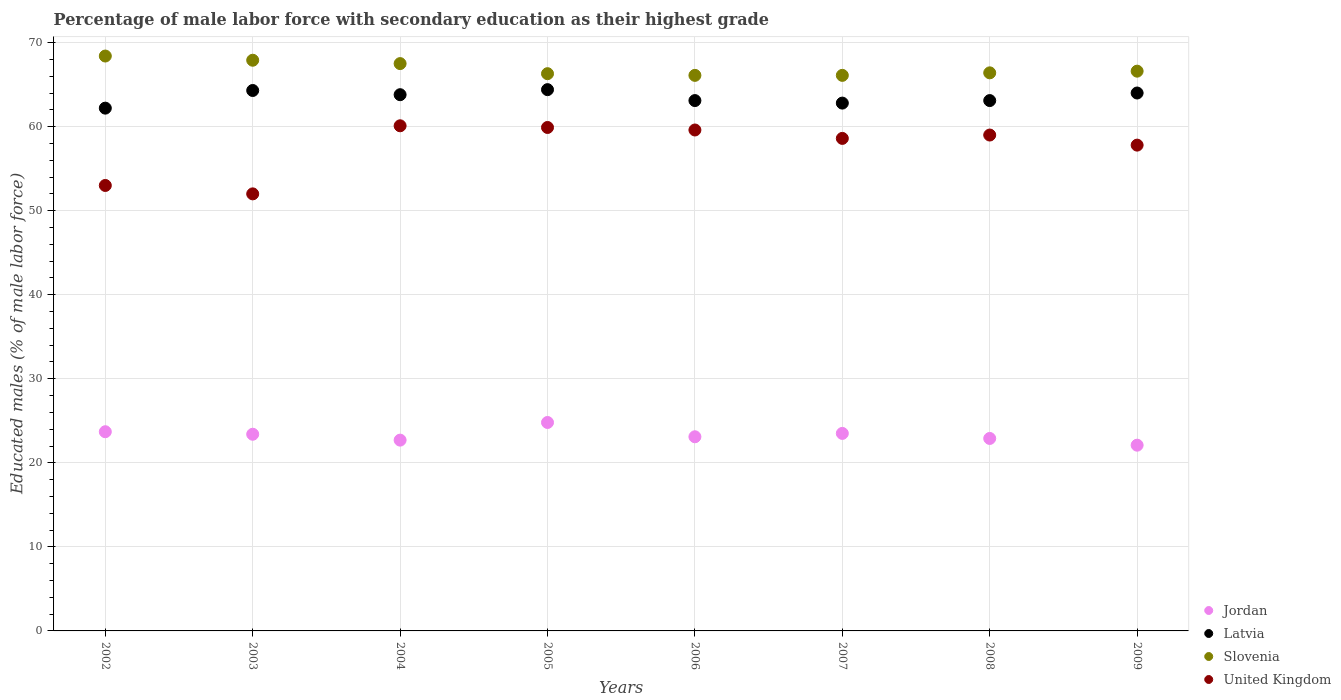What is the percentage of male labor force with secondary education in Slovenia in 2005?
Offer a very short reply. 66.3. Across all years, what is the maximum percentage of male labor force with secondary education in Jordan?
Offer a terse response. 24.8. Across all years, what is the minimum percentage of male labor force with secondary education in Latvia?
Provide a short and direct response. 62.2. What is the total percentage of male labor force with secondary education in Slovenia in the graph?
Provide a short and direct response. 535.3. What is the difference between the percentage of male labor force with secondary education in Jordan in 2004 and that in 2009?
Give a very brief answer. 0.6. What is the difference between the percentage of male labor force with secondary education in Slovenia in 2005 and the percentage of male labor force with secondary education in Latvia in 2009?
Your answer should be compact. 2.3. What is the average percentage of male labor force with secondary education in Slovenia per year?
Your answer should be compact. 66.91. In the year 2007, what is the difference between the percentage of male labor force with secondary education in United Kingdom and percentage of male labor force with secondary education in Latvia?
Provide a succinct answer. -4.2. In how many years, is the percentage of male labor force with secondary education in Jordan greater than 28 %?
Offer a terse response. 0. What is the ratio of the percentage of male labor force with secondary education in Jordan in 2002 to that in 2006?
Provide a short and direct response. 1.03. Is the difference between the percentage of male labor force with secondary education in United Kingdom in 2002 and 2004 greater than the difference between the percentage of male labor force with secondary education in Latvia in 2002 and 2004?
Keep it short and to the point. No. What is the difference between the highest and the lowest percentage of male labor force with secondary education in Jordan?
Your answer should be very brief. 2.7. How many dotlines are there?
Provide a succinct answer. 4. How many years are there in the graph?
Your answer should be very brief. 8. Are the values on the major ticks of Y-axis written in scientific E-notation?
Your response must be concise. No. Does the graph contain grids?
Offer a very short reply. Yes. How are the legend labels stacked?
Offer a terse response. Vertical. What is the title of the graph?
Make the answer very short. Percentage of male labor force with secondary education as their highest grade. What is the label or title of the Y-axis?
Your response must be concise. Educated males (% of male labor force). What is the Educated males (% of male labor force) in Jordan in 2002?
Give a very brief answer. 23.7. What is the Educated males (% of male labor force) in Latvia in 2002?
Offer a very short reply. 62.2. What is the Educated males (% of male labor force) of Slovenia in 2002?
Provide a succinct answer. 68.4. What is the Educated males (% of male labor force) of United Kingdom in 2002?
Provide a succinct answer. 53. What is the Educated males (% of male labor force) of Jordan in 2003?
Your response must be concise. 23.4. What is the Educated males (% of male labor force) in Latvia in 2003?
Your response must be concise. 64.3. What is the Educated males (% of male labor force) in Slovenia in 2003?
Ensure brevity in your answer.  67.9. What is the Educated males (% of male labor force) in Jordan in 2004?
Ensure brevity in your answer.  22.7. What is the Educated males (% of male labor force) of Latvia in 2004?
Make the answer very short. 63.8. What is the Educated males (% of male labor force) in Slovenia in 2004?
Make the answer very short. 67.5. What is the Educated males (% of male labor force) in United Kingdom in 2004?
Give a very brief answer. 60.1. What is the Educated males (% of male labor force) of Jordan in 2005?
Your response must be concise. 24.8. What is the Educated males (% of male labor force) of Latvia in 2005?
Your answer should be compact. 64.4. What is the Educated males (% of male labor force) in Slovenia in 2005?
Your response must be concise. 66.3. What is the Educated males (% of male labor force) of United Kingdom in 2005?
Provide a short and direct response. 59.9. What is the Educated males (% of male labor force) in Jordan in 2006?
Provide a succinct answer. 23.1. What is the Educated males (% of male labor force) in Latvia in 2006?
Provide a short and direct response. 63.1. What is the Educated males (% of male labor force) in Slovenia in 2006?
Ensure brevity in your answer.  66.1. What is the Educated males (% of male labor force) of United Kingdom in 2006?
Provide a short and direct response. 59.6. What is the Educated males (% of male labor force) of Latvia in 2007?
Your response must be concise. 62.8. What is the Educated males (% of male labor force) of Slovenia in 2007?
Your answer should be compact. 66.1. What is the Educated males (% of male labor force) of United Kingdom in 2007?
Give a very brief answer. 58.6. What is the Educated males (% of male labor force) of Jordan in 2008?
Keep it short and to the point. 22.9. What is the Educated males (% of male labor force) in Latvia in 2008?
Keep it short and to the point. 63.1. What is the Educated males (% of male labor force) in Slovenia in 2008?
Your response must be concise. 66.4. What is the Educated males (% of male labor force) of United Kingdom in 2008?
Give a very brief answer. 59. What is the Educated males (% of male labor force) of Jordan in 2009?
Provide a succinct answer. 22.1. What is the Educated males (% of male labor force) in Slovenia in 2009?
Provide a short and direct response. 66.6. What is the Educated males (% of male labor force) in United Kingdom in 2009?
Your answer should be very brief. 57.8. Across all years, what is the maximum Educated males (% of male labor force) of Jordan?
Offer a terse response. 24.8. Across all years, what is the maximum Educated males (% of male labor force) in Latvia?
Give a very brief answer. 64.4. Across all years, what is the maximum Educated males (% of male labor force) of Slovenia?
Provide a short and direct response. 68.4. Across all years, what is the maximum Educated males (% of male labor force) of United Kingdom?
Provide a succinct answer. 60.1. Across all years, what is the minimum Educated males (% of male labor force) of Jordan?
Give a very brief answer. 22.1. Across all years, what is the minimum Educated males (% of male labor force) in Latvia?
Your response must be concise. 62.2. Across all years, what is the minimum Educated males (% of male labor force) in Slovenia?
Make the answer very short. 66.1. What is the total Educated males (% of male labor force) of Jordan in the graph?
Keep it short and to the point. 186.2. What is the total Educated males (% of male labor force) in Latvia in the graph?
Offer a very short reply. 507.7. What is the total Educated males (% of male labor force) in Slovenia in the graph?
Give a very brief answer. 535.3. What is the total Educated males (% of male labor force) of United Kingdom in the graph?
Your response must be concise. 460. What is the difference between the Educated males (% of male labor force) of Jordan in 2002 and that in 2004?
Your response must be concise. 1. What is the difference between the Educated males (% of male labor force) in Latvia in 2002 and that in 2004?
Offer a terse response. -1.6. What is the difference between the Educated males (% of male labor force) of Slovenia in 2002 and that in 2004?
Give a very brief answer. 0.9. What is the difference between the Educated males (% of male labor force) in Jordan in 2002 and that in 2005?
Keep it short and to the point. -1.1. What is the difference between the Educated males (% of male labor force) of Latvia in 2002 and that in 2005?
Make the answer very short. -2.2. What is the difference between the Educated males (% of male labor force) of Jordan in 2002 and that in 2006?
Your response must be concise. 0.6. What is the difference between the Educated males (% of male labor force) of Latvia in 2002 and that in 2006?
Keep it short and to the point. -0.9. What is the difference between the Educated males (% of male labor force) of Slovenia in 2002 and that in 2006?
Offer a terse response. 2.3. What is the difference between the Educated males (% of male labor force) in Latvia in 2002 and that in 2008?
Keep it short and to the point. -0.9. What is the difference between the Educated males (% of male labor force) in Slovenia in 2002 and that in 2008?
Offer a very short reply. 2. What is the difference between the Educated males (% of male labor force) in United Kingdom in 2002 and that in 2008?
Your response must be concise. -6. What is the difference between the Educated males (% of male labor force) in Slovenia in 2002 and that in 2009?
Offer a terse response. 1.8. What is the difference between the Educated males (% of male labor force) in United Kingdom in 2002 and that in 2009?
Ensure brevity in your answer.  -4.8. What is the difference between the Educated males (% of male labor force) in Latvia in 2003 and that in 2004?
Provide a short and direct response. 0.5. What is the difference between the Educated males (% of male labor force) of Slovenia in 2003 and that in 2004?
Give a very brief answer. 0.4. What is the difference between the Educated males (% of male labor force) of Jordan in 2003 and that in 2005?
Offer a terse response. -1.4. What is the difference between the Educated males (% of male labor force) of Latvia in 2003 and that in 2005?
Provide a short and direct response. -0.1. What is the difference between the Educated males (% of male labor force) in Jordan in 2003 and that in 2006?
Your answer should be very brief. 0.3. What is the difference between the Educated males (% of male labor force) in Slovenia in 2003 and that in 2006?
Your answer should be very brief. 1.8. What is the difference between the Educated males (% of male labor force) of United Kingdom in 2003 and that in 2007?
Provide a short and direct response. -6.6. What is the difference between the Educated males (% of male labor force) in Slovenia in 2003 and that in 2008?
Offer a terse response. 1.5. What is the difference between the Educated males (% of male labor force) in United Kingdom in 2003 and that in 2008?
Give a very brief answer. -7. What is the difference between the Educated males (% of male labor force) in Latvia in 2003 and that in 2009?
Your answer should be very brief. 0.3. What is the difference between the Educated males (% of male labor force) of Jordan in 2004 and that in 2006?
Your answer should be very brief. -0.4. What is the difference between the Educated males (% of male labor force) in United Kingdom in 2004 and that in 2006?
Your response must be concise. 0.5. What is the difference between the Educated males (% of male labor force) in Slovenia in 2004 and that in 2007?
Your response must be concise. 1.4. What is the difference between the Educated males (% of male labor force) of Latvia in 2004 and that in 2008?
Keep it short and to the point. 0.7. What is the difference between the Educated males (% of male labor force) of Slovenia in 2004 and that in 2009?
Offer a terse response. 0.9. What is the difference between the Educated males (% of male labor force) of United Kingdom in 2004 and that in 2009?
Provide a succinct answer. 2.3. What is the difference between the Educated males (% of male labor force) of Jordan in 2005 and that in 2006?
Your response must be concise. 1.7. What is the difference between the Educated males (% of male labor force) of Latvia in 2005 and that in 2006?
Provide a short and direct response. 1.3. What is the difference between the Educated males (% of male labor force) of Jordan in 2005 and that in 2007?
Give a very brief answer. 1.3. What is the difference between the Educated males (% of male labor force) of United Kingdom in 2005 and that in 2007?
Ensure brevity in your answer.  1.3. What is the difference between the Educated males (% of male labor force) in United Kingdom in 2005 and that in 2008?
Offer a terse response. 0.9. What is the difference between the Educated males (% of male labor force) of United Kingdom in 2005 and that in 2009?
Give a very brief answer. 2.1. What is the difference between the Educated males (% of male labor force) in Latvia in 2006 and that in 2007?
Make the answer very short. 0.3. What is the difference between the Educated males (% of male labor force) in Slovenia in 2006 and that in 2007?
Make the answer very short. 0. What is the difference between the Educated males (% of male labor force) of United Kingdom in 2006 and that in 2007?
Offer a very short reply. 1. What is the difference between the Educated males (% of male labor force) in Slovenia in 2006 and that in 2008?
Offer a terse response. -0.3. What is the difference between the Educated males (% of male labor force) of United Kingdom in 2006 and that in 2008?
Your answer should be compact. 0.6. What is the difference between the Educated males (% of male labor force) in Latvia in 2006 and that in 2009?
Give a very brief answer. -0.9. What is the difference between the Educated males (% of male labor force) in United Kingdom in 2006 and that in 2009?
Keep it short and to the point. 1.8. What is the difference between the Educated males (% of male labor force) of Jordan in 2007 and that in 2008?
Offer a terse response. 0.6. What is the difference between the Educated males (% of male labor force) of Latvia in 2007 and that in 2008?
Give a very brief answer. -0.3. What is the difference between the Educated males (% of male labor force) in Latvia in 2007 and that in 2009?
Provide a succinct answer. -1.2. What is the difference between the Educated males (% of male labor force) in United Kingdom in 2007 and that in 2009?
Give a very brief answer. 0.8. What is the difference between the Educated males (% of male labor force) of Latvia in 2008 and that in 2009?
Offer a very short reply. -0.9. What is the difference between the Educated males (% of male labor force) of Slovenia in 2008 and that in 2009?
Your response must be concise. -0.2. What is the difference between the Educated males (% of male labor force) in United Kingdom in 2008 and that in 2009?
Ensure brevity in your answer.  1.2. What is the difference between the Educated males (% of male labor force) of Jordan in 2002 and the Educated males (% of male labor force) of Latvia in 2003?
Your response must be concise. -40.6. What is the difference between the Educated males (% of male labor force) of Jordan in 2002 and the Educated males (% of male labor force) of Slovenia in 2003?
Offer a very short reply. -44.2. What is the difference between the Educated males (% of male labor force) of Jordan in 2002 and the Educated males (% of male labor force) of United Kingdom in 2003?
Give a very brief answer. -28.3. What is the difference between the Educated males (% of male labor force) in Latvia in 2002 and the Educated males (% of male labor force) in Slovenia in 2003?
Give a very brief answer. -5.7. What is the difference between the Educated males (% of male labor force) in Latvia in 2002 and the Educated males (% of male labor force) in United Kingdom in 2003?
Your response must be concise. 10.2. What is the difference between the Educated males (% of male labor force) of Slovenia in 2002 and the Educated males (% of male labor force) of United Kingdom in 2003?
Your answer should be very brief. 16.4. What is the difference between the Educated males (% of male labor force) of Jordan in 2002 and the Educated males (% of male labor force) of Latvia in 2004?
Offer a terse response. -40.1. What is the difference between the Educated males (% of male labor force) of Jordan in 2002 and the Educated males (% of male labor force) of Slovenia in 2004?
Keep it short and to the point. -43.8. What is the difference between the Educated males (% of male labor force) in Jordan in 2002 and the Educated males (% of male labor force) in United Kingdom in 2004?
Ensure brevity in your answer.  -36.4. What is the difference between the Educated males (% of male labor force) of Latvia in 2002 and the Educated males (% of male labor force) of Slovenia in 2004?
Keep it short and to the point. -5.3. What is the difference between the Educated males (% of male labor force) in Slovenia in 2002 and the Educated males (% of male labor force) in United Kingdom in 2004?
Ensure brevity in your answer.  8.3. What is the difference between the Educated males (% of male labor force) of Jordan in 2002 and the Educated males (% of male labor force) of Latvia in 2005?
Your answer should be compact. -40.7. What is the difference between the Educated males (% of male labor force) in Jordan in 2002 and the Educated males (% of male labor force) in Slovenia in 2005?
Your response must be concise. -42.6. What is the difference between the Educated males (% of male labor force) of Jordan in 2002 and the Educated males (% of male labor force) of United Kingdom in 2005?
Keep it short and to the point. -36.2. What is the difference between the Educated males (% of male labor force) of Latvia in 2002 and the Educated males (% of male labor force) of United Kingdom in 2005?
Offer a very short reply. 2.3. What is the difference between the Educated males (% of male labor force) of Jordan in 2002 and the Educated males (% of male labor force) of Latvia in 2006?
Your answer should be very brief. -39.4. What is the difference between the Educated males (% of male labor force) of Jordan in 2002 and the Educated males (% of male labor force) of Slovenia in 2006?
Keep it short and to the point. -42.4. What is the difference between the Educated males (% of male labor force) in Jordan in 2002 and the Educated males (% of male labor force) in United Kingdom in 2006?
Offer a very short reply. -35.9. What is the difference between the Educated males (% of male labor force) of Slovenia in 2002 and the Educated males (% of male labor force) of United Kingdom in 2006?
Your answer should be very brief. 8.8. What is the difference between the Educated males (% of male labor force) of Jordan in 2002 and the Educated males (% of male labor force) of Latvia in 2007?
Offer a very short reply. -39.1. What is the difference between the Educated males (% of male labor force) in Jordan in 2002 and the Educated males (% of male labor force) in Slovenia in 2007?
Your response must be concise. -42.4. What is the difference between the Educated males (% of male labor force) in Jordan in 2002 and the Educated males (% of male labor force) in United Kingdom in 2007?
Make the answer very short. -34.9. What is the difference between the Educated males (% of male labor force) in Latvia in 2002 and the Educated males (% of male labor force) in United Kingdom in 2007?
Keep it short and to the point. 3.6. What is the difference between the Educated males (% of male labor force) in Slovenia in 2002 and the Educated males (% of male labor force) in United Kingdom in 2007?
Ensure brevity in your answer.  9.8. What is the difference between the Educated males (% of male labor force) in Jordan in 2002 and the Educated males (% of male labor force) in Latvia in 2008?
Ensure brevity in your answer.  -39.4. What is the difference between the Educated males (% of male labor force) in Jordan in 2002 and the Educated males (% of male labor force) in Slovenia in 2008?
Make the answer very short. -42.7. What is the difference between the Educated males (% of male labor force) of Jordan in 2002 and the Educated males (% of male labor force) of United Kingdom in 2008?
Your response must be concise. -35.3. What is the difference between the Educated males (% of male labor force) in Latvia in 2002 and the Educated males (% of male labor force) in United Kingdom in 2008?
Give a very brief answer. 3.2. What is the difference between the Educated males (% of male labor force) of Jordan in 2002 and the Educated males (% of male labor force) of Latvia in 2009?
Give a very brief answer. -40.3. What is the difference between the Educated males (% of male labor force) in Jordan in 2002 and the Educated males (% of male labor force) in Slovenia in 2009?
Provide a short and direct response. -42.9. What is the difference between the Educated males (% of male labor force) of Jordan in 2002 and the Educated males (% of male labor force) of United Kingdom in 2009?
Provide a succinct answer. -34.1. What is the difference between the Educated males (% of male labor force) in Latvia in 2002 and the Educated males (% of male labor force) in Slovenia in 2009?
Give a very brief answer. -4.4. What is the difference between the Educated males (% of male labor force) in Latvia in 2002 and the Educated males (% of male labor force) in United Kingdom in 2009?
Offer a very short reply. 4.4. What is the difference between the Educated males (% of male labor force) of Slovenia in 2002 and the Educated males (% of male labor force) of United Kingdom in 2009?
Make the answer very short. 10.6. What is the difference between the Educated males (% of male labor force) in Jordan in 2003 and the Educated males (% of male labor force) in Latvia in 2004?
Give a very brief answer. -40.4. What is the difference between the Educated males (% of male labor force) of Jordan in 2003 and the Educated males (% of male labor force) of Slovenia in 2004?
Provide a short and direct response. -44.1. What is the difference between the Educated males (% of male labor force) in Jordan in 2003 and the Educated males (% of male labor force) in United Kingdom in 2004?
Offer a very short reply. -36.7. What is the difference between the Educated males (% of male labor force) in Latvia in 2003 and the Educated males (% of male labor force) in Slovenia in 2004?
Keep it short and to the point. -3.2. What is the difference between the Educated males (% of male labor force) in Slovenia in 2003 and the Educated males (% of male labor force) in United Kingdom in 2004?
Keep it short and to the point. 7.8. What is the difference between the Educated males (% of male labor force) in Jordan in 2003 and the Educated males (% of male labor force) in Latvia in 2005?
Provide a succinct answer. -41. What is the difference between the Educated males (% of male labor force) of Jordan in 2003 and the Educated males (% of male labor force) of Slovenia in 2005?
Keep it short and to the point. -42.9. What is the difference between the Educated males (% of male labor force) in Jordan in 2003 and the Educated males (% of male labor force) in United Kingdom in 2005?
Offer a very short reply. -36.5. What is the difference between the Educated males (% of male labor force) in Latvia in 2003 and the Educated males (% of male labor force) in Slovenia in 2005?
Make the answer very short. -2. What is the difference between the Educated males (% of male labor force) of Jordan in 2003 and the Educated males (% of male labor force) of Latvia in 2006?
Ensure brevity in your answer.  -39.7. What is the difference between the Educated males (% of male labor force) of Jordan in 2003 and the Educated males (% of male labor force) of Slovenia in 2006?
Provide a succinct answer. -42.7. What is the difference between the Educated males (% of male labor force) in Jordan in 2003 and the Educated males (% of male labor force) in United Kingdom in 2006?
Make the answer very short. -36.2. What is the difference between the Educated males (% of male labor force) of Jordan in 2003 and the Educated males (% of male labor force) of Latvia in 2007?
Your answer should be very brief. -39.4. What is the difference between the Educated males (% of male labor force) of Jordan in 2003 and the Educated males (% of male labor force) of Slovenia in 2007?
Keep it short and to the point. -42.7. What is the difference between the Educated males (% of male labor force) in Jordan in 2003 and the Educated males (% of male labor force) in United Kingdom in 2007?
Provide a short and direct response. -35.2. What is the difference between the Educated males (% of male labor force) in Latvia in 2003 and the Educated males (% of male labor force) in Slovenia in 2007?
Your response must be concise. -1.8. What is the difference between the Educated males (% of male labor force) of Jordan in 2003 and the Educated males (% of male labor force) of Latvia in 2008?
Ensure brevity in your answer.  -39.7. What is the difference between the Educated males (% of male labor force) of Jordan in 2003 and the Educated males (% of male labor force) of Slovenia in 2008?
Provide a short and direct response. -43. What is the difference between the Educated males (% of male labor force) in Jordan in 2003 and the Educated males (% of male labor force) in United Kingdom in 2008?
Give a very brief answer. -35.6. What is the difference between the Educated males (% of male labor force) of Latvia in 2003 and the Educated males (% of male labor force) of Slovenia in 2008?
Keep it short and to the point. -2.1. What is the difference between the Educated males (% of male labor force) in Latvia in 2003 and the Educated males (% of male labor force) in United Kingdom in 2008?
Make the answer very short. 5.3. What is the difference between the Educated males (% of male labor force) in Jordan in 2003 and the Educated males (% of male labor force) in Latvia in 2009?
Keep it short and to the point. -40.6. What is the difference between the Educated males (% of male labor force) in Jordan in 2003 and the Educated males (% of male labor force) in Slovenia in 2009?
Ensure brevity in your answer.  -43.2. What is the difference between the Educated males (% of male labor force) in Jordan in 2003 and the Educated males (% of male labor force) in United Kingdom in 2009?
Offer a very short reply. -34.4. What is the difference between the Educated males (% of male labor force) of Jordan in 2004 and the Educated males (% of male labor force) of Latvia in 2005?
Ensure brevity in your answer.  -41.7. What is the difference between the Educated males (% of male labor force) of Jordan in 2004 and the Educated males (% of male labor force) of Slovenia in 2005?
Make the answer very short. -43.6. What is the difference between the Educated males (% of male labor force) in Jordan in 2004 and the Educated males (% of male labor force) in United Kingdom in 2005?
Provide a short and direct response. -37.2. What is the difference between the Educated males (% of male labor force) in Latvia in 2004 and the Educated males (% of male labor force) in United Kingdom in 2005?
Your answer should be very brief. 3.9. What is the difference between the Educated males (% of male labor force) of Jordan in 2004 and the Educated males (% of male labor force) of Latvia in 2006?
Your answer should be compact. -40.4. What is the difference between the Educated males (% of male labor force) of Jordan in 2004 and the Educated males (% of male labor force) of Slovenia in 2006?
Your response must be concise. -43.4. What is the difference between the Educated males (% of male labor force) in Jordan in 2004 and the Educated males (% of male labor force) in United Kingdom in 2006?
Offer a very short reply. -36.9. What is the difference between the Educated males (% of male labor force) of Latvia in 2004 and the Educated males (% of male labor force) of Slovenia in 2006?
Your answer should be compact. -2.3. What is the difference between the Educated males (% of male labor force) of Jordan in 2004 and the Educated males (% of male labor force) of Latvia in 2007?
Ensure brevity in your answer.  -40.1. What is the difference between the Educated males (% of male labor force) in Jordan in 2004 and the Educated males (% of male labor force) in Slovenia in 2007?
Offer a terse response. -43.4. What is the difference between the Educated males (% of male labor force) in Jordan in 2004 and the Educated males (% of male labor force) in United Kingdom in 2007?
Give a very brief answer. -35.9. What is the difference between the Educated males (% of male labor force) of Latvia in 2004 and the Educated males (% of male labor force) of United Kingdom in 2007?
Keep it short and to the point. 5.2. What is the difference between the Educated males (% of male labor force) in Jordan in 2004 and the Educated males (% of male labor force) in Latvia in 2008?
Keep it short and to the point. -40.4. What is the difference between the Educated males (% of male labor force) in Jordan in 2004 and the Educated males (% of male labor force) in Slovenia in 2008?
Provide a short and direct response. -43.7. What is the difference between the Educated males (% of male labor force) in Jordan in 2004 and the Educated males (% of male labor force) in United Kingdom in 2008?
Your answer should be compact. -36.3. What is the difference between the Educated males (% of male labor force) in Latvia in 2004 and the Educated males (% of male labor force) in Slovenia in 2008?
Provide a short and direct response. -2.6. What is the difference between the Educated males (% of male labor force) in Slovenia in 2004 and the Educated males (% of male labor force) in United Kingdom in 2008?
Provide a short and direct response. 8.5. What is the difference between the Educated males (% of male labor force) in Jordan in 2004 and the Educated males (% of male labor force) in Latvia in 2009?
Ensure brevity in your answer.  -41.3. What is the difference between the Educated males (% of male labor force) in Jordan in 2004 and the Educated males (% of male labor force) in Slovenia in 2009?
Provide a succinct answer. -43.9. What is the difference between the Educated males (% of male labor force) in Jordan in 2004 and the Educated males (% of male labor force) in United Kingdom in 2009?
Give a very brief answer. -35.1. What is the difference between the Educated males (% of male labor force) in Jordan in 2005 and the Educated males (% of male labor force) in Latvia in 2006?
Offer a terse response. -38.3. What is the difference between the Educated males (% of male labor force) in Jordan in 2005 and the Educated males (% of male labor force) in Slovenia in 2006?
Give a very brief answer. -41.3. What is the difference between the Educated males (% of male labor force) of Jordan in 2005 and the Educated males (% of male labor force) of United Kingdom in 2006?
Ensure brevity in your answer.  -34.8. What is the difference between the Educated males (% of male labor force) of Latvia in 2005 and the Educated males (% of male labor force) of United Kingdom in 2006?
Offer a terse response. 4.8. What is the difference between the Educated males (% of male labor force) of Jordan in 2005 and the Educated males (% of male labor force) of Latvia in 2007?
Your answer should be compact. -38. What is the difference between the Educated males (% of male labor force) in Jordan in 2005 and the Educated males (% of male labor force) in Slovenia in 2007?
Give a very brief answer. -41.3. What is the difference between the Educated males (% of male labor force) of Jordan in 2005 and the Educated males (% of male labor force) of United Kingdom in 2007?
Provide a short and direct response. -33.8. What is the difference between the Educated males (% of male labor force) in Latvia in 2005 and the Educated males (% of male labor force) in Slovenia in 2007?
Your answer should be compact. -1.7. What is the difference between the Educated males (% of male labor force) in Latvia in 2005 and the Educated males (% of male labor force) in United Kingdom in 2007?
Keep it short and to the point. 5.8. What is the difference between the Educated males (% of male labor force) in Slovenia in 2005 and the Educated males (% of male labor force) in United Kingdom in 2007?
Provide a short and direct response. 7.7. What is the difference between the Educated males (% of male labor force) of Jordan in 2005 and the Educated males (% of male labor force) of Latvia in 2008?
Your answer should be very brief. -38.3. What is the difference between the Educated males (% of male labor force) in Jordan in 2005 and the Educated males (% of male labor force) in Slovenia in 2008?
Provide a short and direct response. -41.6. What is the difference between the Educated males (% of male labor force) of Jordan in 2005 and the Educated males (% of male labor force) of United Kingdom in 2008?
Give a very brief answer. -34.2. What is the difference between the Educated males (% of male labor force) of Latvia in 2005 and the Educated males (% of male labor force) of Slovenia in 2008?
Provide a short and direct response. -2. What is the difference between the Educated males (% of male labor force) in Latvia in 2005 and the Educated males (% of male labor force) in United Kingdom in 2008?
Offer a terse response. 5.4. What is the difference between the Educated males (% of male labor force) in Jordan in 2005 and the Educated males (% of male labor force) in Latvia in 2009?
Offer a terse response. -39.2. What is the difference between the Educated males (% of male labor force) of Jordan in 2005 and the Educated males (% of male labor force) of Slovenia in 2009?
Ensure brevity in your answer.  -41.8. What is the difference between the Educated males (% of male labor force) in Jordan in 2005 and the Educated males (% of male labor force) in United Kingdom in 2009?
Ensure brevity in your answer.  -33. What is the difference between the Educated males (% of male labor force) of Latvia in 2005 and the Educated males (% of male labor force) of Slovenia in 2009?
Provide a succinct answer. -2.2. What is the difference between the Educated males (% of male labor force) in Slovenia in 2005 and the Educated males (% of male labor force) in United Kingdom in 2009?
Make the answer very short. 8.5. What is the difference between the Educated males (% of male labor force) in Jordan in 2006 and the Educated males (% of male labor force) in Latvia in 2007?
Ensure brevity in your answer.  -39.7. What is the difference between the Educated males (% of male labor force) of Jordan in 2006 and the Educated males (% of male labor force) of Slovenia in 2007?
Offer a terse response. -43. What is the difference between the Educated males (% of male labor force) of Jordan in 2006 and the Educated males (% of male labor force) of United Kingdom in 2007?
Offer a very short reply. -35.5. What is the difference between the Educated males (% of male labor force) in Latvia in 2006 and the Educated males (% of male labor force) in United Kingdom in 2007?
Your answer should be very brief. 4.5. What is the difference between the Educated males (% of male labor force) in Slovenia in 2006 and the Educated males (% of male labor force) in United Kingdom in 2007?
Provide a succinct answer. 7.5. What is the difference between the Educated males (% of male labor force) in Jordan in 2006 and the Educated males (% of male labor force) in Latvia in 2008?
Make the answer very short. -40. What is the difference between the Educated males (% of male labor force) in Jordan in 2006 and the Educated males (% of male labor force) in Slovenia in 2008?
Offer a very short reply. -43.3. What is the difference between the Educated males (% of male labor force) in Jordan in 2006 and the Educated males (% of male labor force) in United Kingdom in 2008?
Give a very brief answer. -35.9. What is the difference between the Educated males (% of male labor force) of Latvia in 2006 and the Educated males (% of male labor force) of United Kingdom in 2008?
Make the answer very short. 4.1. What is the difference between the Educated males (% of male labor force) in Jordan in 2006 and the Educated males (% of male labor force) in Latvia in 2009?
Ensure brevity in your answer.  -40.9. What is the difference between the Educated males (% of male labor force) of Jordan in 2006 and the Educated males (% of male labor force) of Slovenia in 2009?
Offer a very short reply. -43.5. What is the difference between the Educated males (% of male labor force) of Jordan in 2006 and the Educated males (% of male labor force) of United Kingdom in 2009?
Keep it short and to the point. -34.7. What is the difference between the Educated males (% of male labor force) of Latvia in 2006 and the Educated males (% of male labor force) of United Kingdom in 2009?
Ensure brevity in your answer.  5.3. What is the difference between the Educated males (% of male labor force) in Slovenia in 2006 and the Educated males (% of male labor force) in United Kingdom in 2009?
Offer a very short reply. 8.3. What is the difference between the Educated males (% of male labor force) of Jordan in 2007 and the Educated males (% of male labor force) of Latvia in 2008?
Give a very brief answer. -39.6. What is the difference between the Educated males (% of male labor force) of Jordan in 2007 and the Educated males (% of male labor force) of Slovenia in 2008?
Make the answer very short. -42.9. What is the difference between the Educated males (% of male labor force) of Jordan in 2007 and the Educated males (% of male labor force) of United Kingdom in 2008?
Make the answer very short. -35.5. What is the difference between the Educated males (% of male labor force) of Jordan in 2007 and the Educated males (% of male labor force) of Latvia in 2009?
Your answer should be compact. -40.5. What is the difference between the Educated males (% of male labor force) in Jordan in 2007 and the Educated males (% of male labor force) in Slovenia in 2009?
Your answer should be very brief. -43.1. What is the difference between the Educated males (% of male labor force) in Jordan in 2007 and the Educated males (% of male labor force) in United Kingdom in 2009?
Give a very brief answer. -34.3. What is the difference between the Educated males (% of male labor force) in Latvia in 2007 and the Educated males (% of male labor force) in Slovenia in 2009?
Offer a terse response. -3.8. What is the difference between the Educated males (% of male labor force) of Jordan in 2008 and the Educated males (% of male labor force) of Latvia in 2009?
Offer a very short reply. -41.1. What is the difference between the Educated males (% of male labor force) in Jordan in 2008 and the Educated males (% of male labor force) in Slovenia in 2009?
Provide a short and direct response. -43.7. What is the difference between the Educated males (% of male labor force) of Jordan in 2008 and the Educated males (% of male labor force) of United Kingdom in 2009?
Ensure brevity in your answer.  -34.9. What is the difference between the Educated males (% of male labor force) of Latvia in 2008 and the Educated males (% of male labor force) of United Kingdom in 2009?
Keep it short and to the point. 5.3. What is the average Educated males (% of male labor force) in Jordan per year?
Your answer should be compact. 23.27. What is the average Educated males (% of male labor force) in Latvia per year?
Make the answer very short. 63.46. What is the average Educated males (% of male labor force) in Slovenia per year?
Keep it short and to the point. 66.91. What is the average Educated males (% of male labor force) of United Kingdom per year?
Provide a succinct answer. 57.5. In the year 2002, what is the difference between the Educated males (% of male labor force) of Jordan and Educated males (% of male labor force) of Latvia?
Provide a succinct answer. -38.5. In the year 2002, what is the difference between the Educated males (% of male labor force) of Jordan and Educated males (% of male labor force) of Slovenia?
Offer a very short reply. -44.7. In the year 2002, what is the difference between the Educated males (% of male labor force) of Jordan and Educated males (% of male labor force) of United Kingdom?
Make the answer very short. -29.3. In the year 2002, what is the difference between the Educated males (% of male labor force) of Latvia and Educated males (% of male labor force) of United Kingdom?
Offer a very short reply. 9.2. In the year 2003, what is the difference between the Educated males (% of male labor force) of Jordan and Educated males (% of male labor force) of Latvia?
Offer a very short reply. -40.9. In the year 2003, what is the difference between the Educated males (% of male labor force) in Jordan and Educated males (% of male labor force) in Slovenia?
Provide a succinct answer. -44.5. In the year 2003, what is the difference between the Educated males (% of male labor force) in Jordan and Educated males (% of male labor force) in United Kingdom?
Make the answer very short. -28.6. In the year 2003, what is the difference between the Educated males (% of male labor force) of Latvia and Educated males (% of male labor force) of Slovenia?
Keep it short and to the point. -3.6. In the year 2003, what is the difference between the Educated males (% of male labor force) in Latvia and Educated males (% of male labor force) in United Kingdom?
Your response must be concise. 12.3. In the year 2004, what is the difference between the Educated males (% of male labor force) in Jordan and Educated males (% of male labor force) in Latvia?
Provide a short and direct response. -41.1. In the year 2004, what is the difference between the Educated males (% of male labor force) in Jordan and Educated males (% of male labor force) in Slovenia?
Ensure brevity in your answer.  -44.8. In the year 2004, what is the difference between the Educated males (% of male labor force) of Jordan and Educated males (% of male labor force) of United Kingdom?
Give a very brief answer. -37.4. In the year 2004, what is the difference between the Educated males (% of male labor force) in Slovenia and Educated males (% of male labor force) in United Kingdom?
Your answer should be very brief. 7.4. In the year 2005, what is the difference between the Educated males (% of male labor force) in Jordan and Educated males (% of male labor force) in Latvia?
Give a very brief answer. -39.6. In the year 2005, what is the difference between the Educated males (% of male labor force) in Jordan and Educated males (% of male labor force) in Slovenia?
Provide a succinct answer. -41.5. In the year 2005, what is the difference between the Educated males (% of male labor force) in Jordan and Educated males (% of male labor force) in United Kingdom?
Ensure brevity in your answer.  -35.1. In the year 2005, what is the difference between the Educated males (% of male labor force) in Latvia and Educated males (% of male labor force) in United Kingdom?
Provide a short and direct response. 4.5. In the year 2005, what is the difference between the Educated males (% of male labor force) of Slovenia and Educated males (% of male labor force) of United Kingdom?
Your response must be concise. 6.4. In the year 2006, what is the difference between the Educated males (% of male labor force) in Jordan and Educated males (% of male labor force) in Latvia?
Your answer should be very brief. -40. In the year 2006, what is the difference between the Educated males (% of male labor force) in Jordan and Educated males (% of male labor force) in Slovenia?
Keep it short and to the point. -43. In the year 2006, what is the difference between the Educated males (% of male labor force) in Jordan and Educated males (% of male labor force) in United Kingdom?
Give a very brief answer. -36.5. In the year 2006, what is the difference between the Educated males (% of male labor force) of Slovenia and Educated males (% of male labor force) of United Kingdom?
Provide a short and direct response. 6.5. In the year 2007, what is the difference between the Educated males (% of male labor force) of Jordan and Educated males (% of male labor force) of Latvia?
Offer a terse response. -39.3. In the year 2007, what is the difference between the Educated males (% of male labor force) in Jordan and Educated males (% of male labor force) in Slovenia?
Provide a short and direct response. -42.6. In the year 2007, what is the difference between the Educated males (% of male labor force) in Jordan and Educated males (% of male labor force) in United Kingdom?
Give a very brief answer. -35.1. In the year 2007, what is the difference between the Educated males (% of male labor force) in Latvia and Educated males (% of male labor force) in Slovenia?
Provide a succinct answer. -3.3. In the year 2007, what is the difference between the Educated males (% of male labor force) in Latvia and Educated males (% of male labor force) in United Kingdom?
Provide a succinct answer. 4.2. In the year 2008, what is the difference between the Educated males (% of male labor force) in Jordan and Educated males (% of male labor force) in Latvia?
Ensure brevity in your answer.  -40.2. In the year 2008, what is the difference between the Educated males (% of male labor force) of Jordan and Educated males (% of male labor force) of Slovenia?
Make the answer very short. -43.5. In the year 2008, what is the difference between the Educated males (% of male labor force) in Jordan and Educated males (% of male labor force) in United Kingdom?
Offer a very short reply. -36.1. In the year 2008, what is the difference between the Educated males (% of male labor force) of Slovenia and Educated males (% of male labor force) of United Kingdom?
Your response must be concise. 7.4. In the year 2009, what is the difference between the Educated males (% of male labor force) in Jordan and Educated males (% of male labor force) in Latvia?
Provide a succinct answer. -41.9. In the year 2009, what is the difference between the Educated males (% of male labor force) in Jordan and Educated males (% of male labor force) in Slovenia?
Ensure brevity in your answer.  -44.5. In the year 2009, what is the difference between the Educated males (% of male labor force) of Jordan and Educated males (% of male labor force) of United Kingdom?
Your answer should be very brief. -35.7. In the year 2009, what is the difference between the Educated males (% of male labor force) in Latvia and Educated males (% of male labor force) in Slovenia?
Keep it short and to the point. -2.6. What is the ratio of the Educated males (% of male labor force) in Jordan in 2002 to that in 2003?
Provide a short and direct response. 1.01. What is the ratio of the Educated males (% of male labor force) of Latvia in 2002 to that in 2003?
Offer a very short reply. 0.97. What is the ratio of the Educated males (% of male labor force) of Slovenia in 2002 to that in 2003?
Provide a short and direct response. 1.01. What is the ratio of the Educated males (% of male labor force) of United Kingdom in 2002 to that in 2003?
Your answer should be compact. 1.02. What is the ratio of the Educated males (% of male labor force) of Jordan in 2002 to that in 2004?
Ensure brevity in your answer.  1.04. What is the ratio of the Educated males (% of male labor force) in Latvia in 2002 to that in 2004?
Your answer should be compact. 0.97. What is the ratio of the Educated males (% of male labor force) of Slovenia in 2002 to that in 2004?
Keep it short and to the point. 1.01. What is the ratio of the Educated males (% of male labor force) of United Kingdom in 2002 to that in 2004?
Your answer should be compact. 0.88. What is the ratio of the Educated males (% of male labor force) in Jordan in 2002 to that in 2005?
Your response must be concise. 0.96. What is the ratio of the Educated males (% of male labor force) of Latvia in 2002 to that in 2005?
Provide a short and direct response. 0.97. What is the ratio of the Educated males (% of male labor force) of Slovenia in 2002 to that in 2005?
Offer a very short reply. 1.03. What is the ratio of the Educated males (% of male labor force) in United Kingdom in 2002 to that in 2005?
Give a very brief answer. 0.88. What is the ratio of the Educated males (% of male labor force) of Jordan in 2002 to that in 2006?
Offer a very short reply. 1.03. What is the ratio of the Educated males (% of male labor force) of Latvia in 2002 to that in 2006?
Provide a short and direct response. 0.99. What is the ratio of the Educated males (% of male labor force) in Slovenia in 2002 to that in 2006?
Ensure brevity in your answer.  1.03. What is the ratio of the Educated males (% of male labor force) of United Kingdom in 2002 to that in 2006?
Keep it short and to the point. 0.89. What is the ratio of the Educated males (% of male labor force) in Jordan in 2002 to that in 2007?
Provide a succinct answer. 1.01. What is the ratio of the Educated males (% of male labor force) of Latvia in 2002 to that in 2007?
Give a very brief answer. 0.99. What is the ratio of the Educated males (% of male labor force) in Slovenia in 2002 to that in 2007?
Keep it short and to the point. 1.03. What is the ratio of the Educated males (% of male labor force) in United Kingdom in 2002 to that in 2007?
Your answer should be very brief. 0.9. What is the ratio of the Educated males (% of male labor force) in Jordan in 2002 to that in 2008?
Offer a terse response. 1.03. What is the ratio of the Educated males (% of male labor force) in Latvia in 2002 to that in 2008?
Ensure brevity in your answer.  0.99. What is the ratio of the Educated males (% of male labor force) in Slovenia in 2002 to that in 2008?
Provide a succinct answer. 1.03. What is the ratio of the Educated males (% of male labor force) in United Kingdom in 2002 to that in 2008?
Your answer should be compact. 0.9. What is the ratio of the Educated males (% of male labor force) in Jordan in 2002 to that in 2009?
Your answer should be very brief. 1.07. What is the ratio of the Educated males (% of male labor force) in Latvia in 2002 to that in 2009?
Your answer should be compact. 0.97. What is the ratio of the Educated males (% of male labor force) in Slovenia in 2002 to that in 2009?
Your response must be concise. 1.03. What is the ratio of the Educated males (% of male labor force) in United Kingdom in 2002 to that in 2009?
Make the answer very short. 0.92. What is the ratio of the Educated males (% of male labor force) of Jordan in 2003 to that in 2004?
Your answer should be very brief. 1.03. What is the ratio of the Educated males (% of male labor force) of Slovenia in 2003 to that in 2004?
Provide a short and direct response. 1.01. What is the ratio of the Educated males (% of male labor force) in United Kingdom in 2003 to that in 2004?
Provide a succinct answer. 0.87. What is the ratio of the Educated males (% of male labor force) of Jordan in 2003 to that in 2005?
Your answer should be compact. 0.94. What is the ratio of the Educated males (% of male labor force) of Latvia in 2003 to that in 2005?
Provide a succinct answer. 1. What is the ratio of the Educated males (% of male labor force) in Slovenia in 2003 to that in 2005?
Provide a succinct answer. 1.02. What is the ratio of the Educated males (% of male labor force) of United Kingdom in 2003 to that in 2005?
Keep it short and to the point. 0.87. What is the ratio of the Educated males (% of male labor force) in Jordan in 2003 to that in 2006?
Make the answer very short. 1.01. What is the ratio of the Educated males (% of male labor force) of Latvia in 2003 to that in 2006?
Make the answer very short. 1.02. What is the ratio of the Educated males (% of male labor force) of Slovenia in 2003 to that in 2006?
Offer a terse response. 1.03. What is the ratio of the Educated males (% of male labor force) of United Kingdom in 2003 to that in 2006?
Provide a short and direct response. 0.87. What is the ratio of the Educated males (% of male labor force) in Latvia in 2003 to that in 2007?
Offer a very short reply. 1.02. What is the ratio of the Educated males (% of male labor force) in Slovenia in 2003 to that in 2007?
Give a very brief answer. 1.03. What is the ratio of the Educated males (% of male labor force) in United Kingdom in 2003 to that in 2007?
Keep it short and to the point. 0.89. What is the ratio of the Educated males (% of male labor force) of Jordan in 2003 to that in 2008?
Your answer should be compact. 1.02. What is the ratio of the Educated males (% of male labor force) in Slovenia in 2003 to that in 2008?
Provide a succinct answer. 1.02. What is the ratio of the Educated males (% of male labor force) of United Kingdom in 2003 to that in 2008?
Provide a short and direct response. 0.88. What is the ratio of the Educated males (% of male labor force) of Jordan in 2003 to that in 2009?
Offer a terse response. 1.06. What is the ratio of the Educated males (% of male labor force) of Latvia in 2003 to that in 2009?
Provide a succinct answer. 1. What is the ratio of the Educated males (% of male labor force) in Slovenia in 2003 to that in 2009?
Ensure brevity in your answer.  1.02. What is the ratio of the Educated males (% of male labor force) of United Kingdom in 2003 to that in 2009?
Give a very brief answer. 0.9. What is the ratio of the Educated males (% of male labor force) of Jordan in 2004 to that in 2005?
Ensure brevity in your answer.  0.92. What is the ratio of the Educated males (% of male labor force) of Latvia in 2004 to that in 2005?
Your response must be concise. 0.99. What is the ratio of the Educated males (% of male labor force) in Slovenia in 2004 to that in 2005?
Keep it short and to the point. 1.02. What is the ratio of the Educated males (% of male labor force) of Jordan in 2004 to that in 2006?
Make the answer very short. 0.98. What is the ratio of the Educated males (% of male labor force) in Latvia in 2004 to that in 2006?
Ensure brevity in your answer.  1.01. What is the ratio of the Educated males (% of male labor force) in Slovenia in 2004 to that in 2006?
Provide a succinct answer. 1.02. What is the ratio of the Educated males (% of male labor force) of United Kingdom in 2004 to that in 2006?
Offer a terse response. 1.01. What is the ratio of the Educated males (% of male labor force) of Jordan in 2004 to that in 2007?
Keep it short and to the point. 0.97. What is the ratio of the Educated males (% of male labor force) of Latvia in 2004 to that in 2007?
Make the answer very short. 1.02. What is the ratio of the Educated males (% of male labor force) of Slovenia in 2004 to that in 2007?
Keep it short and to the point. 1.02. What is the ratio of the Educated males (% of male labor force) in United Kingdom in 2004 to that in 2007?
Ensure brevity in your answer.  1.03. What is the ratio of the Educated males (% of male labor force) of Latvia in 2004 to that in 2008?
Ensure brevity in your answer.  1.01. What is the ratio of the Educated males (% of male labor force) of Slovenia in 2004 to that in 2008?
Your answer should be very brief. 1.02. What is the ratio of the Educated males (% of male labor force) in United Kingdom in 2004 to that in 2008?
Your answer should be compact. 1.02. What is the ratio of the Educated males (% of male labor force) in Jordan in 2004 to that in 2009?
Keep it short and to the point. 1.03. What is the ratio of the Educated males (% of male labor force) of Slovenia in 2004 to that in 2009?
Offer a terse response. 1.01. What is the ratio of the Educated males (% of male labor force) of United Kingdom in 2004 to that in 2009?
Keep it short and to the point. 1.04. What is the ratio of the Educated males (% of male labor force) in Jordan in 2005 to that in 2006?
Your answer should be compact. 1.07. What is the ratio of the Educated males (% of male labor force) in Latvia in 2005 to that in 2006?
Provide a short and direct response. 1.02. What is the ratio of the Educated males (% of male labor force) in United Kingdom in 2005 to that in 2006?
Your response must be concise. 1. What is the ratio of the Educated males (% of male labor force) in Jordan in 2005 to that in 2007?
Your response must be concise. 1.06. What is the ratio of the Educated males (% of male labor force) in Latvia in 2005 to that in 2007?
Your answer should be very brief. 1.03. What is the ratio of the Educated males (% of male labor force) in Slovenia in 2005 to that in 2007?
Your answer should be very brief. 1. What is the ratio of the Educated males (% of male labor force) in United Kingdom in 2005 to that in 2007?
Your response must be concise. 1.02. What is the ratio of the Educated males (% of male labor force) of Jordan in 2005 to that in 2008?
Make the answer very short. 1.08. What is the ratio of the Educated males (% of male labor force) of Latvia in 2005 to that in 2008?
Provide a succinct answer. 1.02. What is the ratio of the Educated males (% of male labor force) in United Kingdom in 2005 to that in 2008?
Make the answer very short. 1.02. What is the ratio of the Educated males (% of male labor force) in Jordan in 2005 to that in 2009?
Your answer should be very brief. 1.12. What is the ratio of the Educated males (% of male labor force) of Latvia in 2005 to that in 2009?
Your answer should be compact. 1.01. What is the ratio of the Educated males (% of male labor force) of United Kingdom in 2005 to that in 2009?
Your answer should be very brief. 1.04. What is the ratio of the Educated males (% of male labor force) in Latvia in 2006 to that in 2007?
Ensure brevity in your answer.  1. What is the ratio of the Educated males (% of male labor force) in Slovenia in 2006 to that in 2007?
Provide a short and direct response. 1. What is the ratio of the Educated males (% of male labor force) of United Kingdom in 2006 to that in 2007?
Make the answer very short. 1.02. What is the ratio of the Educated males (% of male labor force) of Jordan in 2006 to that in 2008?
Make the answer very short. 1.01. What is the ratio of the Educated males (% of male labor force) of Latvia in 2006 to that in 2008?
Give a very brief answer. 1. What is the ratio of the Educated males (% of male labor force) in United Kingdom in 2006 to that in 2008?
Provide a succinct answer. 1.01. What is the ratio of the Educated males (% of male labor force) in Jordan in 2006 to that in 2009?
Offer a very short reply. 1.05. What is the ratio of the Educated males (% of male labor force) in Latvia in 2006 to that in 2009?
Make the answer very short. 0.99. What is the ratio of the Educated males (% of male labor force) in United Kingdom in 2006 to that in 2009?
Provide a succinct answer. 1.03. What is the ratio of the Educated males (% of male labor force) in Jordan in 2007 to that in 2008?
Give a very brief answer. 1.03. What is the ratio of the Educated males (% of male labor force) of Latvia in 2007 to that in 2008?
Offer a terse response. 1. What is the ratio of the Educated males (% of male labor force) in Slovenia in 2007 to that in 2008?
Provide a succinct answer. 1. What is the ratio of the Educated males (% of male labor force) in United Kingdom in 2007 to that in 2008?
Keep it short and to the point. 0.99. What is the ratio of the Educated males (% of male labor force) in Jordan in 2007 to that in 2009?
Make the answer very short. 1.06. What is the ratio of the Educated males (% of male labor force) in Latvia in 2007 to that in 2009?
Your answer should be very brief. 0.98. What is the ratio of the Educated males (% of male labor force) in Slovenia in 2007 to that in 2009?
Keep it short and to the point. 0.99. What is the ratio of the Educated males (% of male labor force) of United Kingdom in 2007 to that in 2009?
Provide a short and direct response. 1.01. What is the ratio of the Educated males (% of male labor force) in Jordan in 2008 to that in 2009?
Ensure brevity in your answer.  1.04. What is the ratio of the Educated males (% of male labor force) in Latvia in 2008 to that in 2009?
Ensure brevity in your answer.  0.99. What is the ratio of the Educated males (% of male labor force) of Slovenia in 2008 to that in 2009?
Your answer should be very brief. 1. What is the ratio of the Educated males (% of male labor force) in United Kingdom in 2008 to that in 2009?
Ensure brevity in your answer.  1.02. What is the difference between the highest and the second highest Educated males (% of male labor force) in Jordan?
Give a very brief answer. 1.1. What is the difference between the highest and the second highest Educated males (% of male labor force) in United Kingdom?
Provide a succinct answer. 0.2. What is the difference between the highest and the lowest Educated males (% of male labor force) of Jordan?
Your answer should be compact. 2.7. What is the difference between the highest and the lowest Educated males (% of male labor force) of United Kingdom?
Make the answer very short. 8.1. 